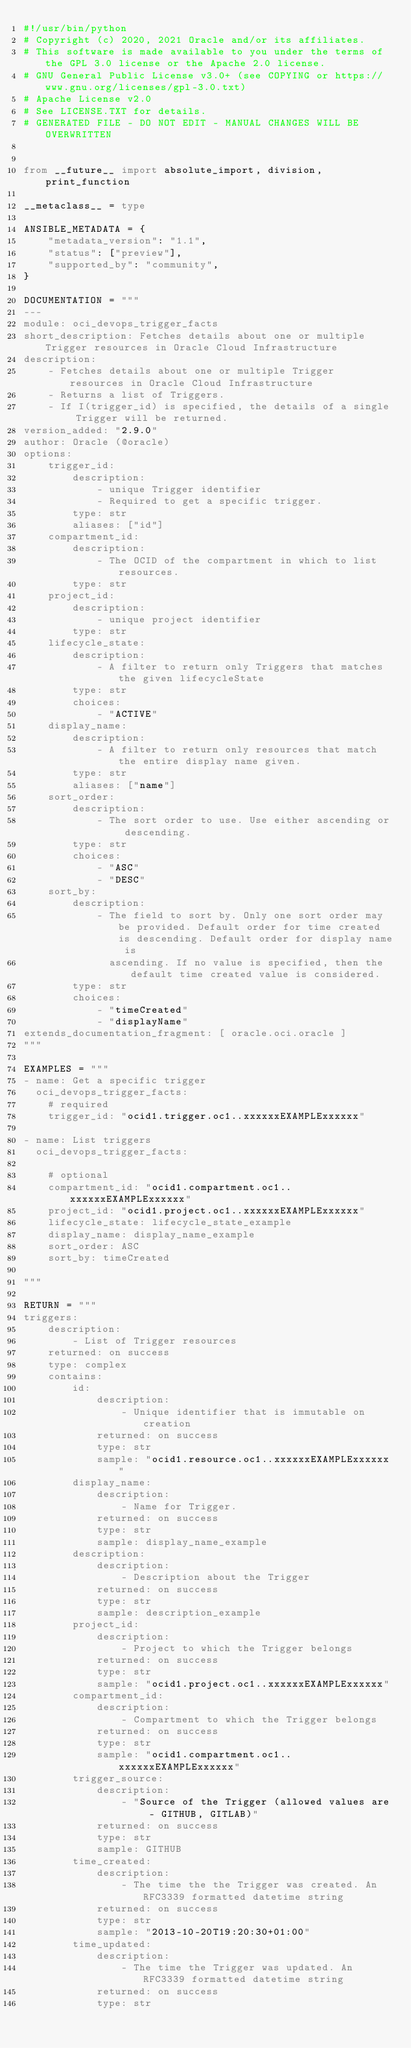Convert code to text. <code><loc_0><loc_0><loc_500><loc_500><_Python_>#!/usr/bin/python
# Copyright (c) 2020, 2021 Oracle and/or its affiliates.
# This software is made available to you under the terms of the GPL 3.0 license or the Apache 2.0 license.
# GNU General Public License v3.0+ (see COPYING or https://www.gnu.org/licenses/gpl-3.0.txt)
# Apache License v2.0
# See LICENSE.TXT for details.
# GENERATED FILE - DO NOT EDIT - MANUAL CHANGES WILL BE OVERWRITTEN


from __future__ import absolute_import, division, print_function

__metaclass__ = type

ANSIBLE_METADATA = {
    "metadata_version": "1.1",
    "status": ["preview"],
    "supported_by": "community",
}

DOCUMENTATION = """
---
module: oci_devops_trigger_facts
short_description: Fetches details about one or multiple Trigger resources in Oracle Cloud Infrastructure
description:
    - Fetches details about one or multiple Trigger resources in Oracle Cloud Infrastructure
    - Returns a list of Triggers.
    - If I(trigger_id) is specified, the details of a single Trigger will be returned.
version_added: "2.9.0"
author: Oracle (@oracle)
options:
    trigger_id:
        description:
            - unique Trigger identifier
            - Required to get a specific trigger.
        type: str
        aliases: ["id"]
    compartment_id:
        description:
            - The OCID of the compartment in which to list resources.
        type: str
    project_id:
        description:
            - unique project identifier
        type: str
    lifecycle_state:
        description:
            - A filter to return only Triggers that matches the given lifecycleState
        type: str
        choices:
            - "ACTIVE"
    display_name:
        description:
            - A filter to return only resources that match the entire display name given.
        type: str
        aliases: ["name"]
    sort_order:
        description:
            - The sort order to use. Use either ascending or descending.
        type: str
        choices:
            - "ASC"
            - "DESC"
    sort_by:
        description:
            - The field to sort by. Only one sort order may be provided. Default order for time created is descending. Default order for display name is
              ascending. If no value is specified, then the default time created value is considered.
        type: str
        choices:
            - "timeCreated"
            - "displayName"
extends_documentation_fragment: [ oracle.oci.oracle ]
"""

EXAMPLES = """
- name: Get a specific trigger
  oci_devops_trigger_facts:
    # required
    trigger_id: "ocid1.trigger.oc1..xxxxxxEXAMPLExxxxxx"

- name: List triggers
  oci_devops_trigger_facts:

    # optional
    compartment_id: "ocid1.compartment.oc1..xxxxxxEXAMPLExxxxxx"
    project_id: "ocid1.project.oc1..xxxxxxEXAMPLExxxxxx"
    lifecycle_state: lifecycle_state_example
    display_name: display_name_example
    sort_order: ASC
    sort_by: timeCreated

"""

RETURN = """
triggers:
    description:
        - List of Trigger resources
    returned: on success
    type: complex
    contains:
        id:
            description:
                - Unique identifier that is immutable on creation
            returned: on success
            type: str
            sample: "ocid1.resource.oc1..xxxxxxEXAMPLExxxxxx"
        display_name:
            description:
                - Name for Trigger.
            returned: on success
            type: str
            sample: display_name_example
        description:
            description:
                - Description about the Trigger
            returned: on success
            type: str
            sample: description_example
        project_id:
            description:
                - Project to which the Trigger belongs
            returned: on success
            type: str
            sample: "ocid1.project.oc1..xxxxxxEXAMPLExxxxxx"
        compartment_id:
            description:
                - Compartment to which the Trigger belongs
            returned: on success
            type: str
            sample: "ocid1.compartment.oc1..xxxxxxEXAMPLExxxxxx"
        trigger_source:
            description:
                - "Source of the Trigger (allowed values are - GITHUB, GITLAB)"
            returned: on success
            type: str
            sample: GITHUB
        time_created:
            description:
                - The time the the Trigger was created. An RFC3339 formatted datetime string
            returned: on success
            type: str
            sample: "2013-10-20T19:20:30+01:00"
        time_updated:
            description:
                - The time the Trigger was updated. An RFC3339 formatted datetime string
            returned: on success
            type: str</code> 